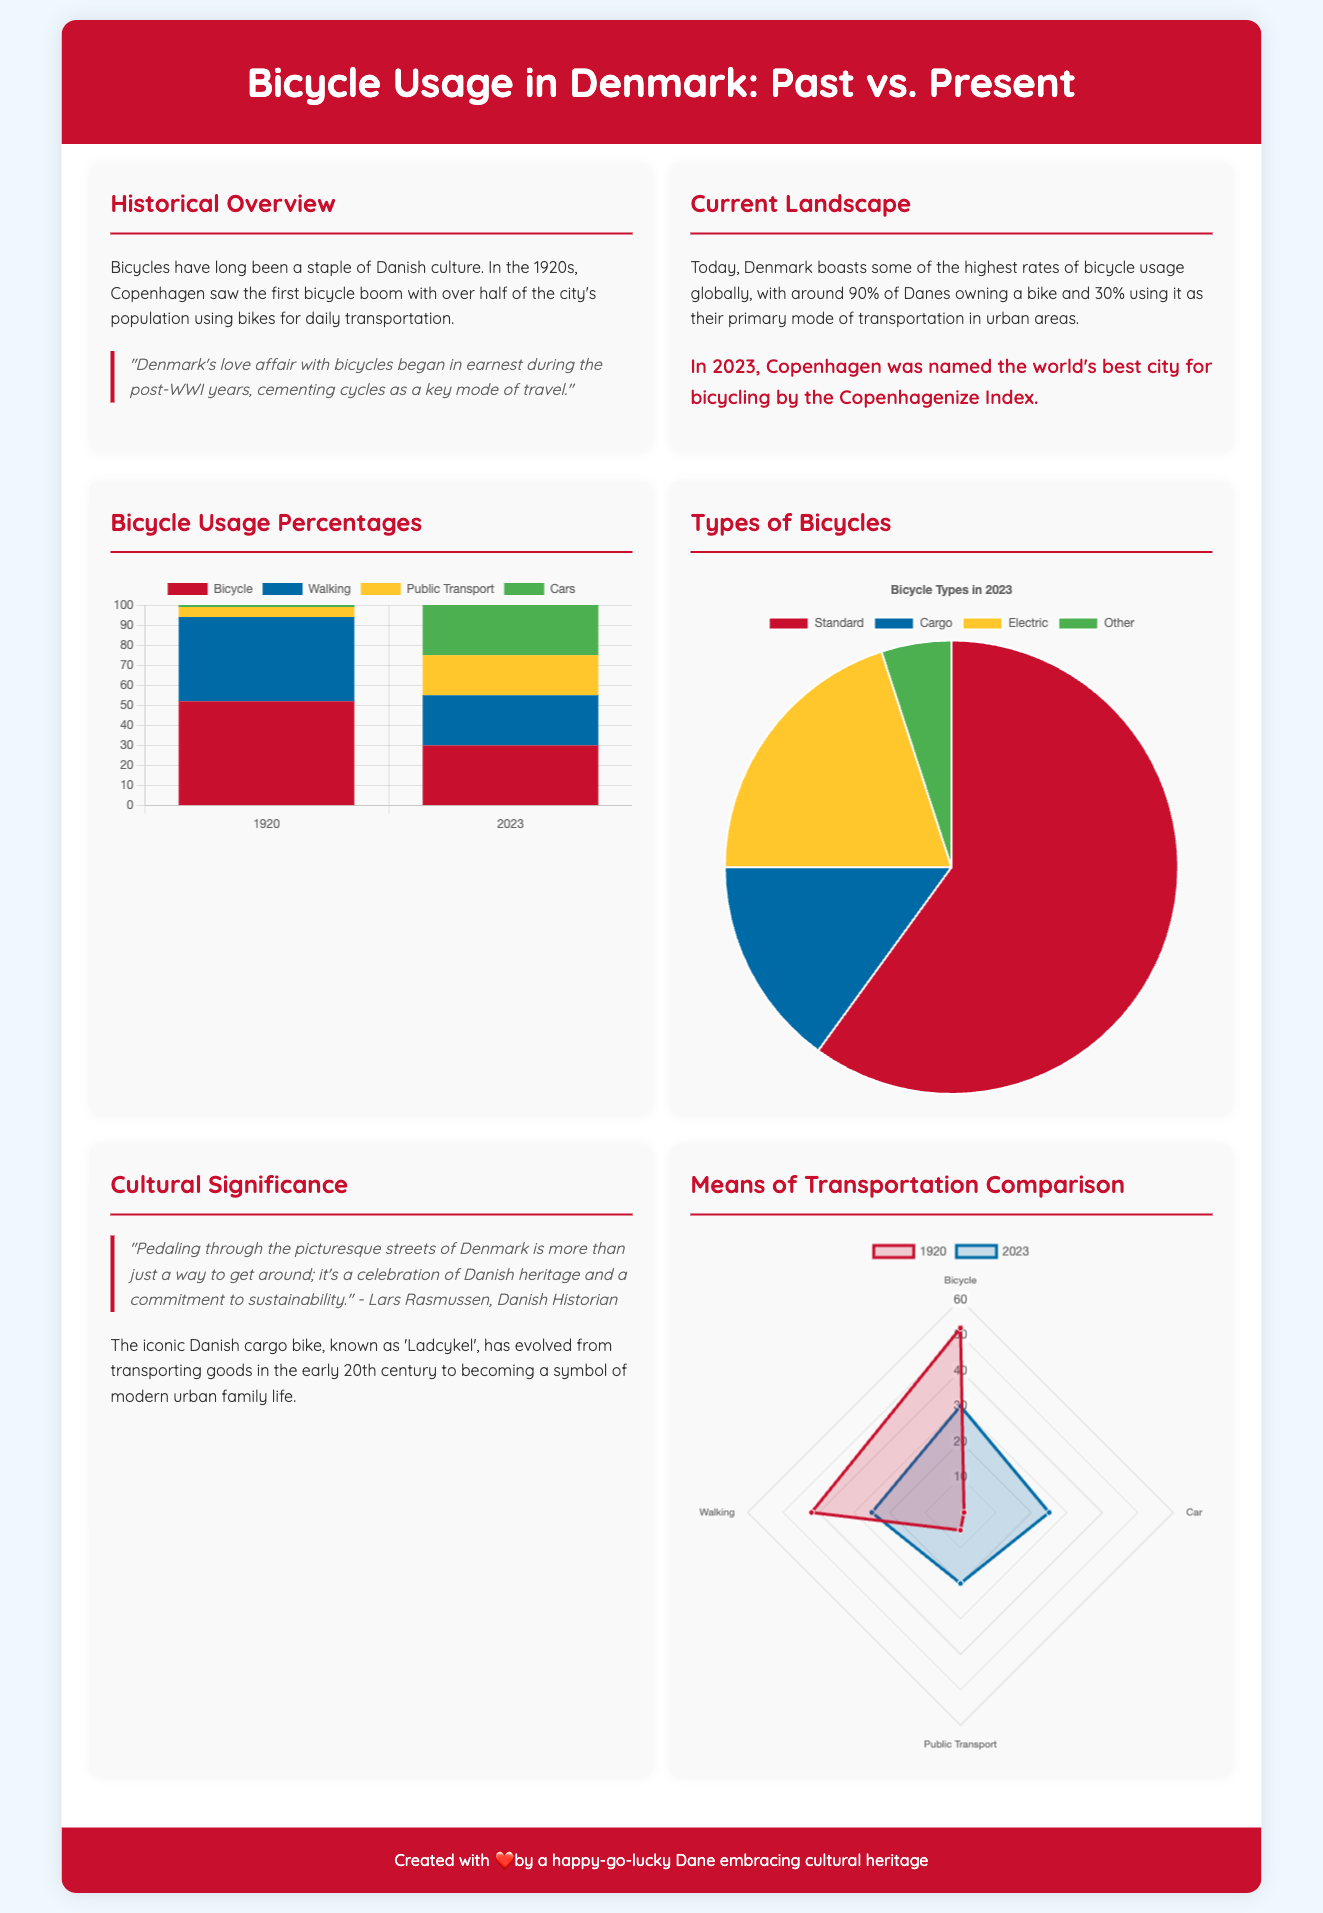what was the percentage of bicycle usage in 1920? The document states that in 1920, the percentage of bicycle usage was 52%.
Answer: 52% what is the percentage of Danes using a bicycle as their primary mode of transportation in 2023? The document mentions that 30% of Danes use a bicycle as their primary mode of transportation in urban areas in 2023.
Answer: 30% which city was named the world's best for bicycling in 2023? The document indicates that Copenhagen was named the world's best city for bicycling.
Answer: Copenhagen what type of bicycle makes up the largest percentage in 2023? The graph shows that Standard bicycles make up the largest percentage of 60% in 2023.
Answer: Standard how much did public transport usage change from 1920 to 2023? The document shows that public transport usage increased from 5% in 1920 to 20% in 2023, indicating a change of 15%.
Answer: 15% what is the primary color of the usage chart for bicycles in 1920? The document specifies that the primary color for bicycles in the usage chart for 1920 is red (#c8102e).
Answer: red what has the cargo bike, or 'Ladcykel', evolved from and into? The document states that the cargo bike has evolved from transporting goods to becoming a symbol of modern urban family life.
Answer: transporting goods to a symbol of modern urban family life what is the color that represents cars in the means of transportation comparison for 2023? The document indicates that the color representing cars in the 2023 comparison is green (#4caf50).
Answer: green what is the historical landmark mentioned for Denmark's bicycle culture beginning? The document notes that the bicycle boom in Copenhagen began in the 1920s.
Answer: 1920s 